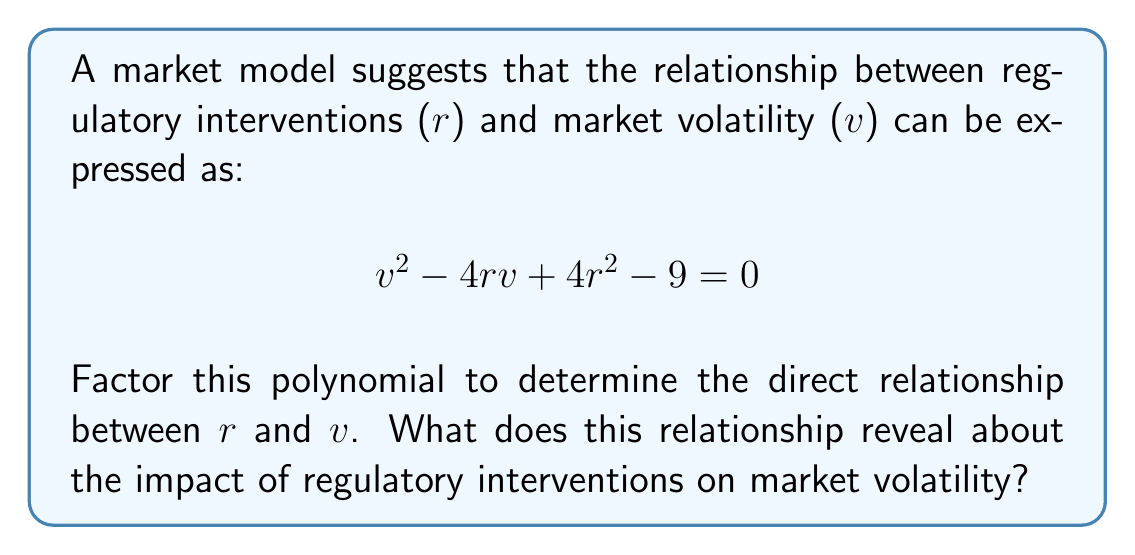What is the answer to this math problem? To factor this polynomial, we'll follow these steps:

1) First, recognize that this is a quadratic equation in terms of v. We can rewrite it as:

   $$v^2 - 4rv + (4r^2 - 9) = 0$$

2) This is in the form $ax^2 + bx + c = 0$, where:
   $a = 1$
   $b = -4r$
   $c = 4r^2 - 9$

3) To factor this, we'll use the perfect square trinomial formula: $x^2 + 2px + p^2 = (x + p)^2$

4) In our case, we need to factor $v^2 - 4rv + 4r^2 - 9$

5) We can rewrite this as: $v^2 - 4rv + 4r^2 - 9 = (v^2 - 4rv + 4r^2) - 9$

6) The first part $(v^2 - 4rv + 4r^2)$ is a perfect square trinomial:
   $(v - 2r)^2 = v^2 - 4rv + 4r^2$

7) So, our equation becomes: $(v - 2r)^2 - 9 = 0$

8) Factor out the 9: $(v - 2r)^2 - 3^2 = 0$

9) This is now in the form of a difference of squares: $a^2 - b^2 = (a+b)(a-b)$

10) Therefore, we can factor it as: $((v - 2r) + 3)((v - 2r) - 3) = 0$

11) Simplifying: $(v - 2r + 3)(v - 2r - 3) = 0$

12) This means: $v = 2r - 3$ or $v = 2r + 3$

This relationship reveals that market volatility (v) is directly proportional to regulatory interventions (r), with two possible outcomes offset by a constant of 3. This suggests that increased regulatory interventions are associated with increased market volatility, but there are two distinct volatility levels for each level of intervention.
Answer: $v = 2r \pm 3$ 